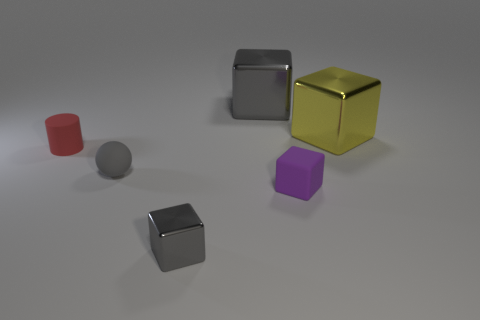Add 2 yellow metal blocks. How many objects exist? 8 Subtract all cylinders. How many objects are left? 5 Add 4 red things. How many red things exist? 5 Subtract 0 yellow balls. How many objects are left? 6 Subtract all tiny spheres. Subtract all large cubes. How many objects are left? 3 Add 3 big cubes. How many big cubes are left? 5 